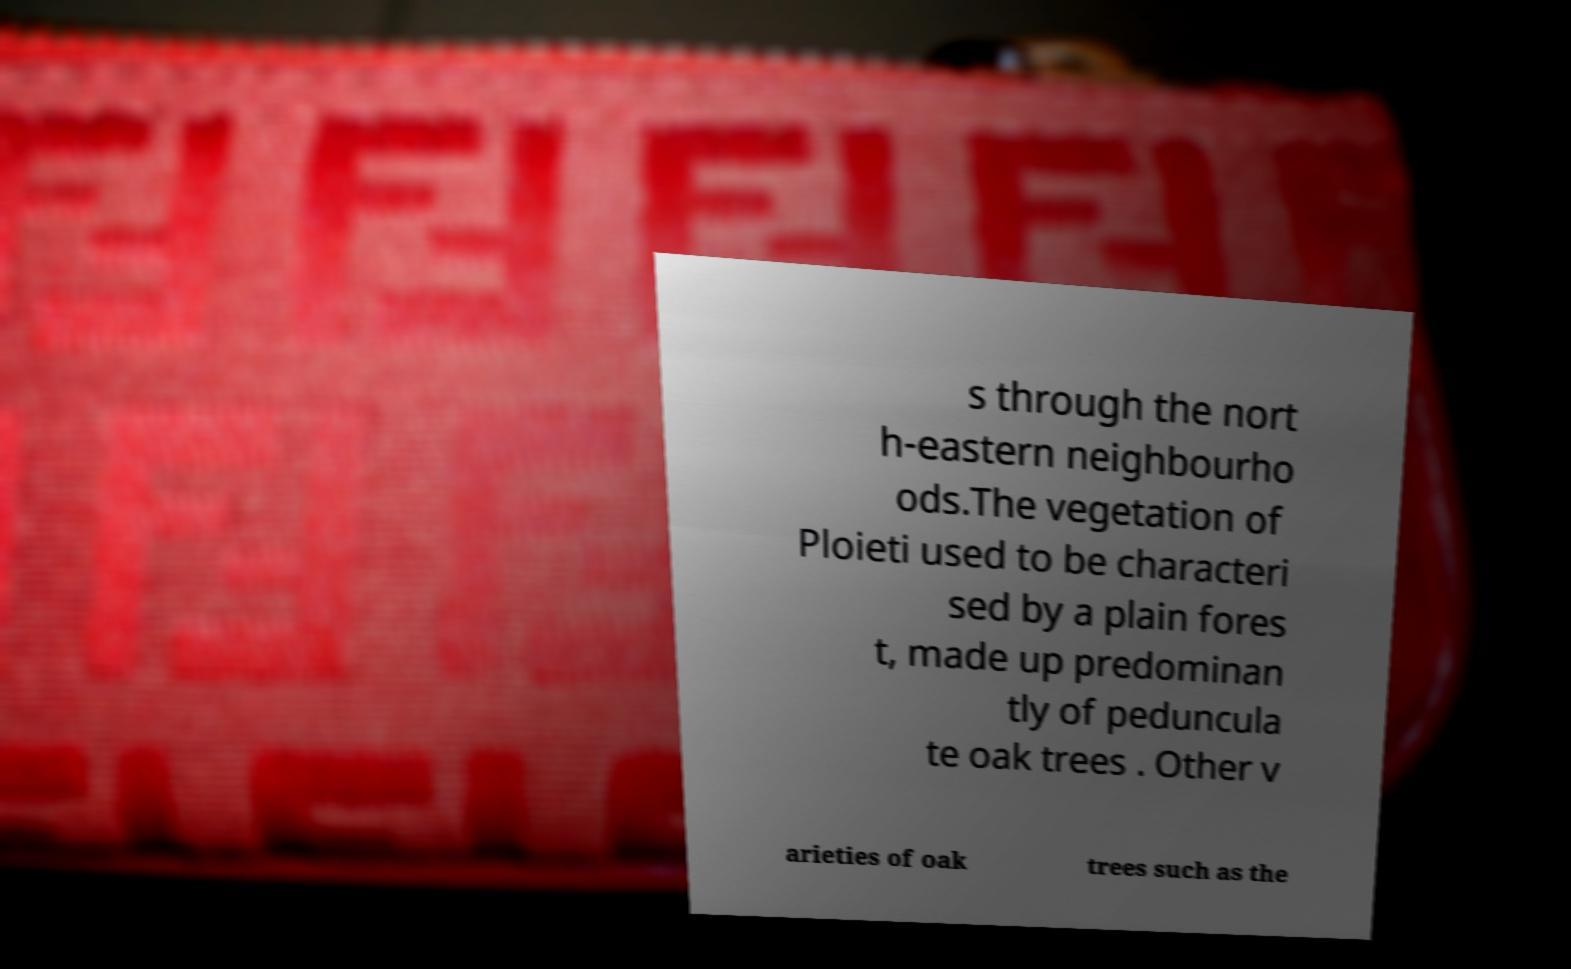What messages or text are displayed in this image? I need them in a readable, typed format. s through the nort h-eastern neighbourho ods.The vegetation of Ploieti used to be characteri sed by a plain fores t, made up predominan tly of peduncula te oak trees . Other v arieties of oak trees such as the 